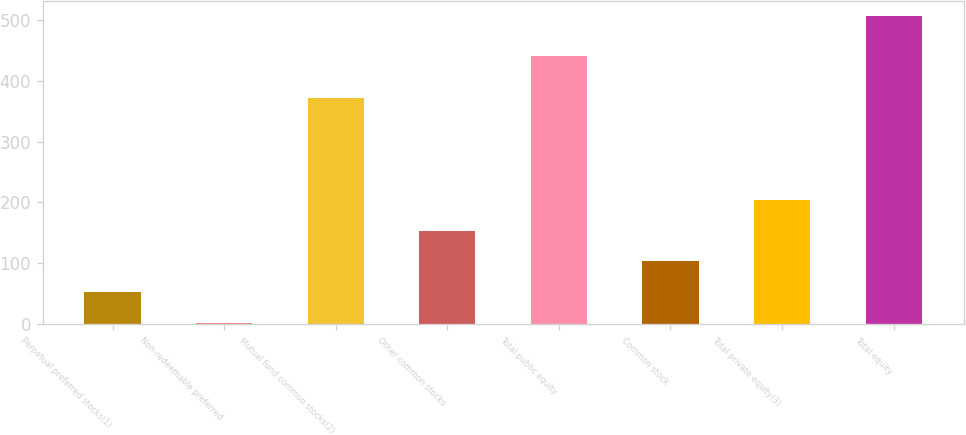Convert chart to OTSL. <chart><loc_0><loc_0><loc_500><loc_500><bar_chart><fcel>Perpetual preferred stocks(1)<fcel>Non-redeemable preferred<fcel>Mutual fund common stocks(2)<fcel>Other common stocks<fcel>Total public equity<fcel>Common stock<fcel>Total private equity(3)<fcel>Total equity<nl><fcel>53.3<fcel>3<fcel>371<fcel>153.9<fcel>440<fcel>103.6<fcel>204.2<fcel>506<nl></chart> 